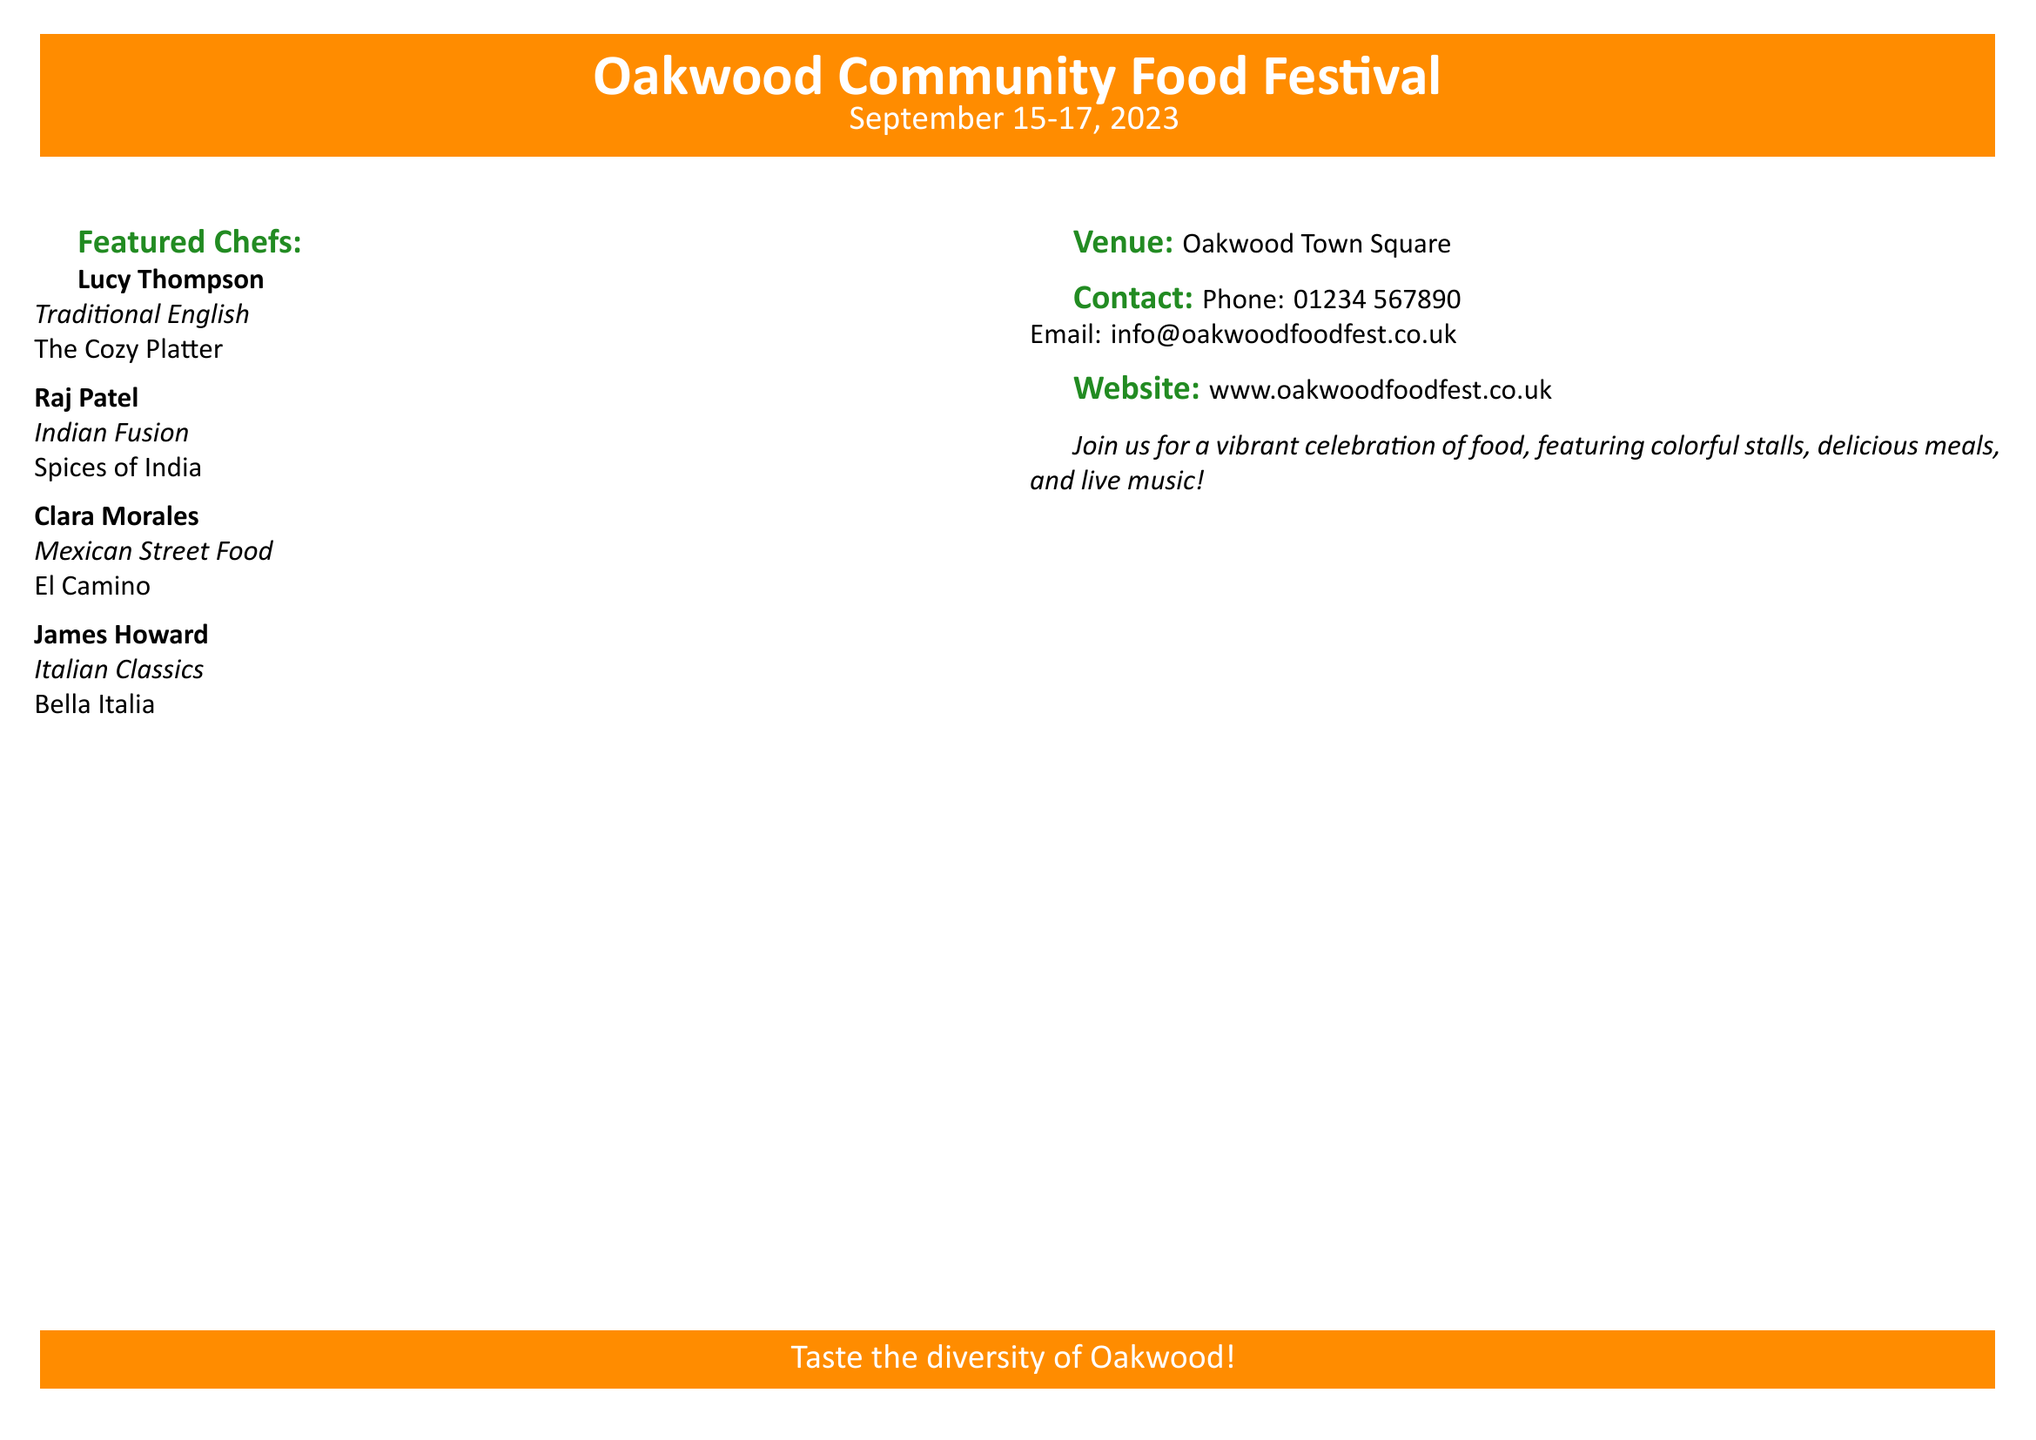What are the event dates? The document specifies the event dates as "September 15-17, 2023."
Answer: September 15-17, 2023 Who is one of the featured chefs? The document lists several featured chefs, one of which is "Lucy Thompson."
Answer: Lucy Thompson What is the venue? The venue for the festival is stated as "Oakwood Town Square."
Answer: Oakwood Town Square What type of cuisine does Raj Patel specialize in? The document indicates Raj Patel specializes in "Indian Fusion."
Answer: Indian Fusion How can someone contact the festival organizers? The document provides a contact phone number as "01234 567890."
Answer: 01234 567890 What is the website for the food festival? The document includes the website as "www.oakwoodfoodfest.co.uk."
Answer: www.oakwoodfoodfest.co.uk How many featured chefs are listed? The document lists a total of four featured chefs.
Answer: Four What is the overall theme of the festival? The document mentions a vibrant celebration featuring colorful stalls, delicious meals, and live music under the theme.
Answer: Celebration of food What color is associated with the festival branding? The document features the color scheme prominently displaying "festive orange."
Answer: Festive orange 